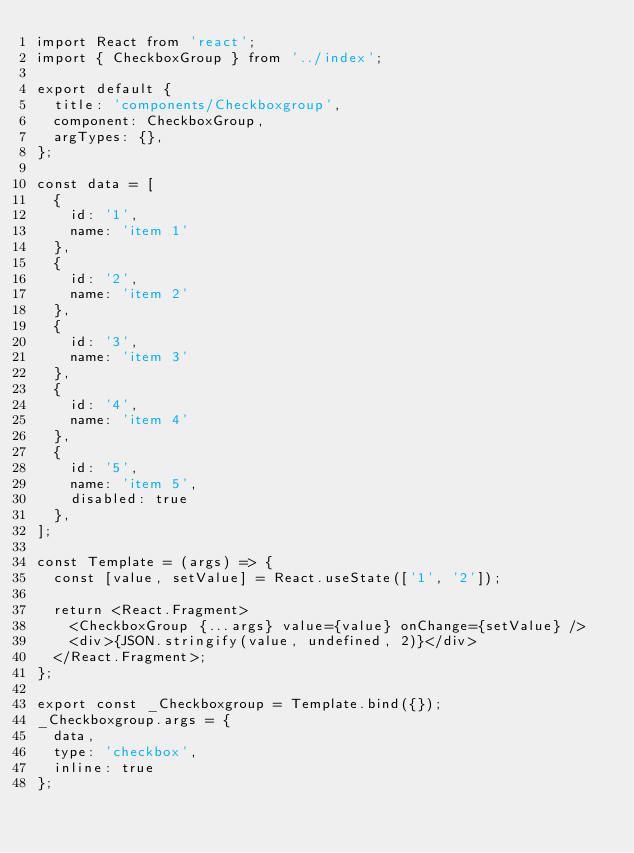<code> <loc_0><loc_0><loc_500><loc_500><_JavaScript_>import React from 'react';
import { CheckboxGroup } from '../index';

export default {
  title: 'components/Checkboxgroup',
  component: CheckboxGroup,
  argTypes: {},
};

const data = [
  {
    id: '1',
    name: 'item 1'
  },
  {
    id: '2',
    name: 'item 2'
  },
  {
    id: '3',
    name: 'item 3'
  },
  {
    id: '4',
    name: 'item 4'
  },
  {
    id: '5',
    name: 'item 5',
    disabled: true
  },
];

const Template = (args) => {
  const [value, setValue] = React.useState(['1', '2']);

  return <React.Fragment>
    <CheckboxGroup {...args} value={value} onChange={setValue} />
    <div>{JSON.stringify(value, undefined, 2)}</div>
  </React.Fragment>;
};

export const _Checkboxgroup = Template.bind({});
_Checkboxgroup.args = {
  data,
  type: 'checkbox',
  inline: true
};
</code> 